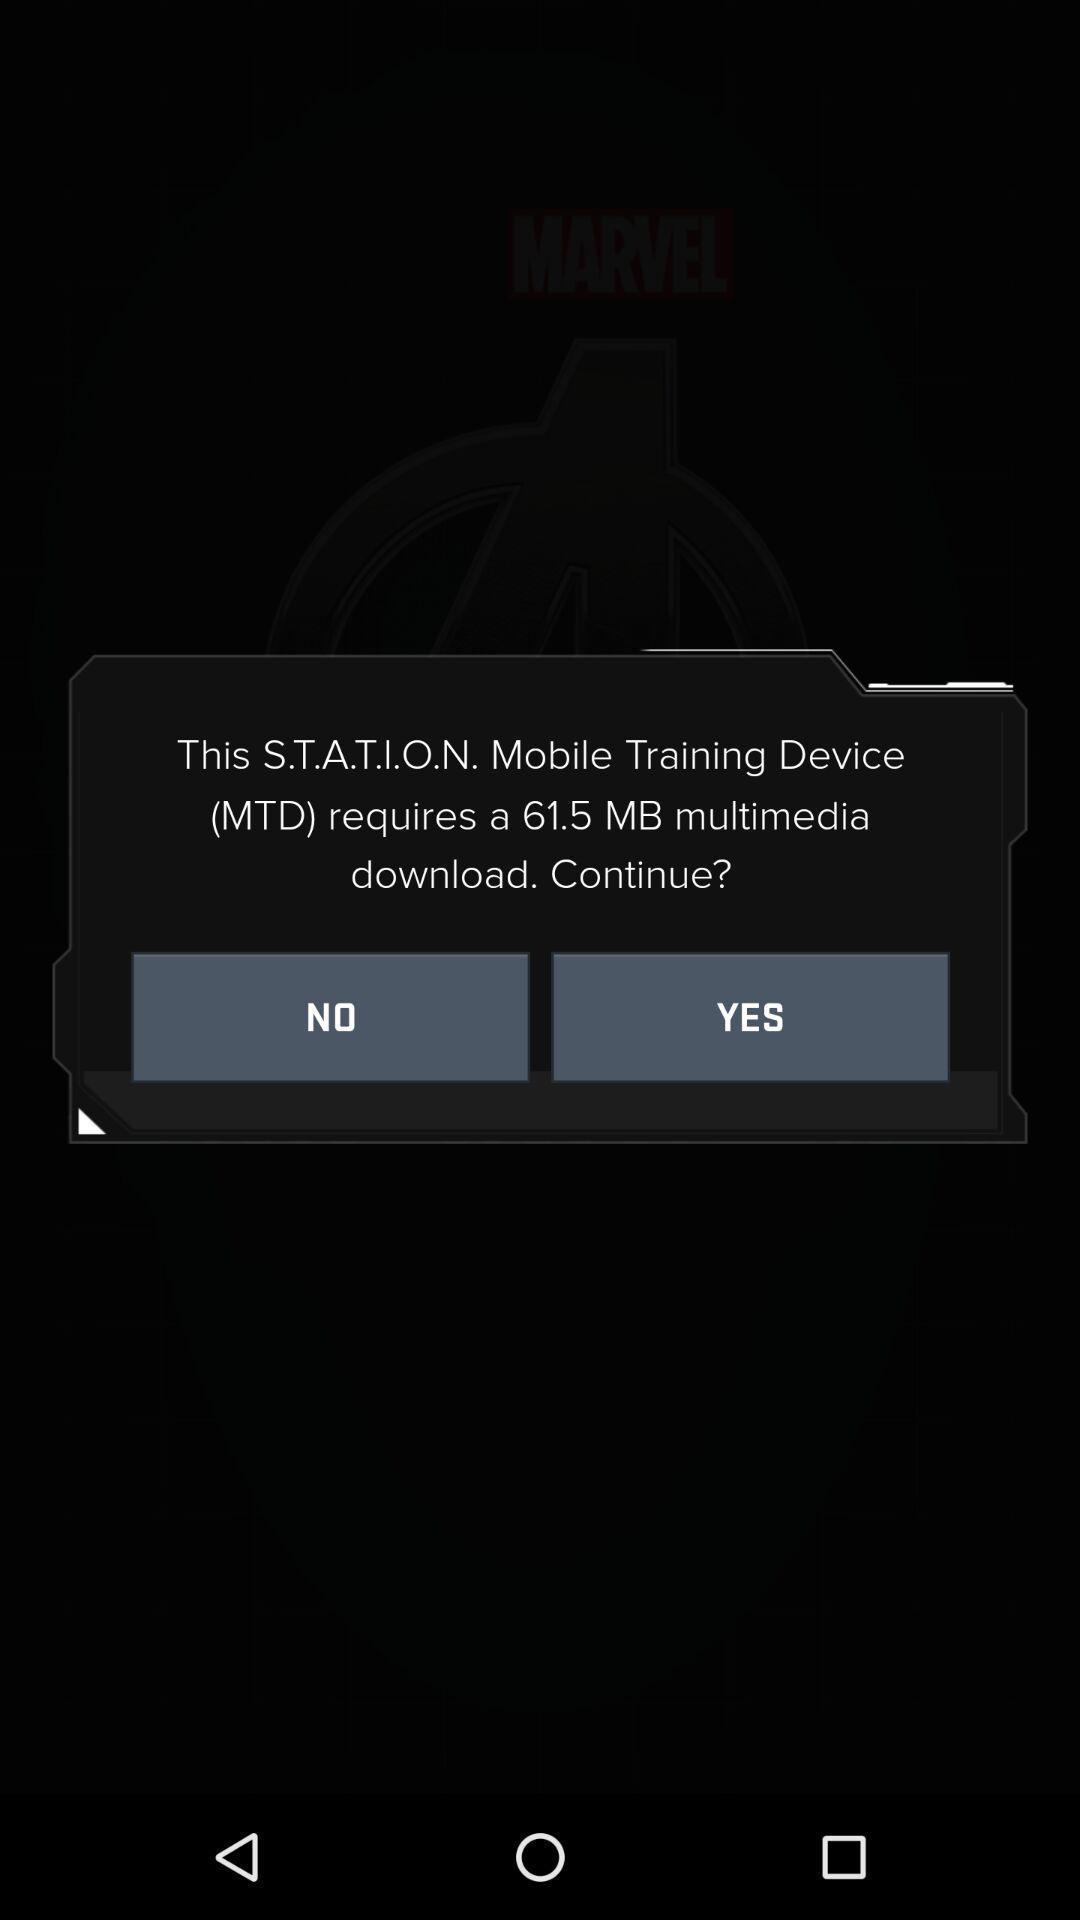Describe the visual elements of this screenshot. Pop-up displaying to download the training app. 